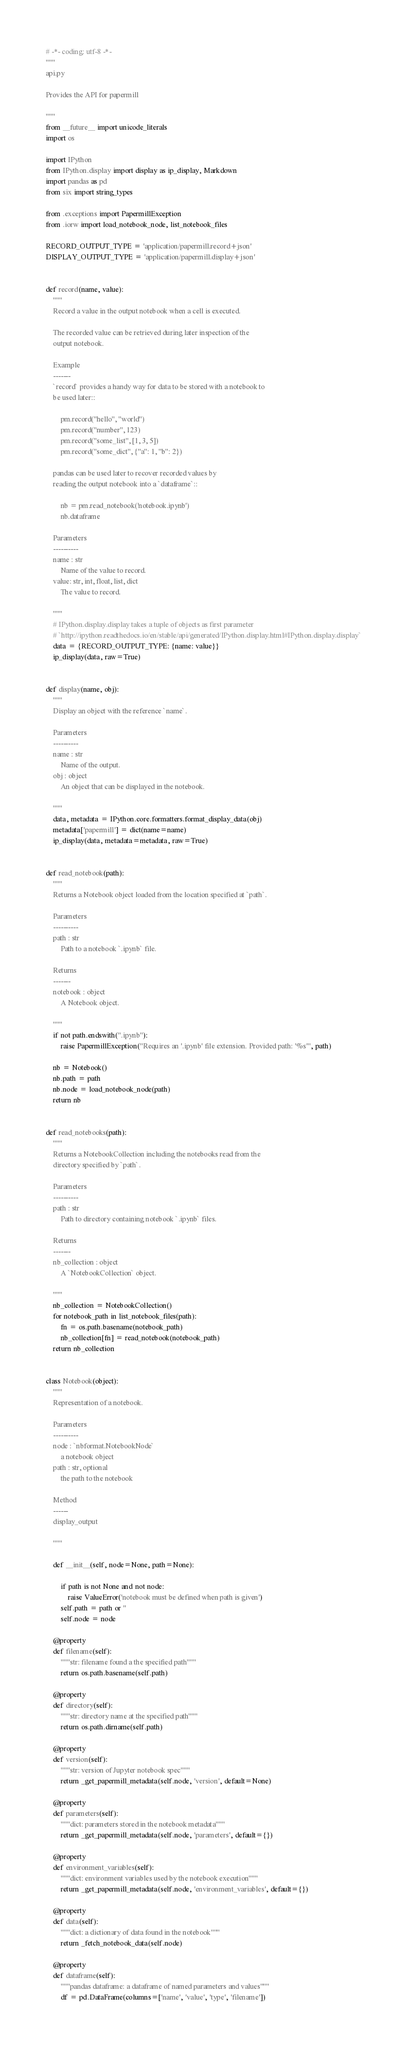<code> <loc_0><loc_0><loc_500><loc_500><_Python_># -*- coding: utf-8 -*-
"""
api.py

Provides the API for papermill

"""
from __future__ import unicode_literals
import os

import IPython
from IPython.display import display as ip_display, Markdown
import pandas as pd
from six import string_types

from .exceptions import PapermillException
from .iorw import load_notebook_node, list_notebook_files

RECORD_OUTPUT_TYPE = 'application/papermill.record+json'
DISPLAY_OUTPUT_TYPE = 'application/papermill.display+json'


def record(name, value):
    """
    Record a value in the output notebook when a cell is executed.

    The recorded value can be retrieved during later inspection of the
    output notebook.

    Example
    -------
    `record` provides a handy way for data to be stored with a notebook to
    be used later::

        pm.record("hello", "world")
        pm.record("number", 123)
        pm.record("some_list", [1, 3, 5])
        pm.record("some_dict", {"a": 1, "b": 2})

    pandas can be used later to recover recorded values by
    reading the output notebook into a `dataframe`::

        nb = pm.read_notebook('notebook.ipynb')
        nb.dataframe

    Parameters
    ----------
    name : str
        Name of the value to record.
    value: str, int, float, list, dict
        The value to record.

    """
    # IPython.display.display takes a tuple of objects as first parameter
    # `http://ipython.readthedocs.io/en/stable/api/generated/IPython.display.html#IPython.display.display`
    data = {RECORD_OUTPUT_TYPE: {name: value}}
    ip_display(data, raw=True)


def display(name, obj):
    """
    Display an object with the reference `name`.

    Parameters
    ----------
    name : str
        Name of the output.
    obj : object
        An object that can be displayed in the notebook.

    """
    data, metadata = IPython.core.formatters.format_display_data(obj)
    metadata['papermill'] = dict(name=name)
    ip_display(data, metadata=metadata, raw=True)


def read_notebook(path):
    """
    Returns a Notebook object loaded from the location specified at `path`.

    Parameters
    ----------
    path : str
        Path to a notebook `.ipynb` file.

    Returns
    -------
    notebook : object
        A Notebook object.

    """
    if not path.endswith(".ipynb"):
        raise PapermillException("Requires an '.ipynb' file extension. Provided path: '%s'", path)

    nb = Notebook()
    nb.path = path
    nb.node = load_notebook_node(path)
    return nb


def read_notebooks(path):
    """
    Returns a NotebookCollection including the notebooks read from the
    directory specified by `path`.

    Parameters
    ----------
    path : str
        Path to directory containing notebook `.ipynb` files.

    Returns
    -------
    nb_collection : object
        A `NotebookCollection` object.

    """
    nb_collection = NotebookCollection()
    for notebook_path in list_notebook_files(path):
        fn = os.path.basename(notebook_path)
        nb_collection[fn] = read_notebook(notebook_path)
    return nb_collection


class Notebook(object):
    """
    Representation of a notebook.

    Parameters
    ----------
    node : `nbformat.NotebookNode`
        a notebook object
    path : str, optional
        the path to the notebook

    Method
    ------
    display_output

    """

    def __init__(self, node=None, path=None):

        if path is not None and not node:
            raise ValueError('notebook must be defined when path is given')
        self.path = path or ''
        self.node = node

    @property
    def filename(self):
        """str: filename found a the specified path"""
        return os.path.basename(self.path)

    @property
    def directory(self):
        """str: directory name at the specified path"""
        return os.path.dirname(self.path)

    @property
    def version(self):
        """str: version of Jupyter notebook spec"""
        return _get_papermill_metadata(self.node, 'version', default=None)

    @property
    def parameters(self):
        """dict: parameters stored in the notebook metadata"""
        return _get_papermill_metadata(self.node, 'parameters', default={})

    @property
    def environment_variables(self):
        """dict: environment variables used by the notebook execution"""
        return _get_papermill_metadata(self.node, 'environment_variables', default={})

    @property
    def data(self):
        """dict: a dictionary of data found in the notebook"""
        return _fetch_notebook_data(self.node)

    @property
    def dataframe(self):
        """pandas dataframe: a dataframe of named parameters and values"""
        df = pd.DataFrame(columns=['name', 'value', 'type', 'filename'])
</code> 